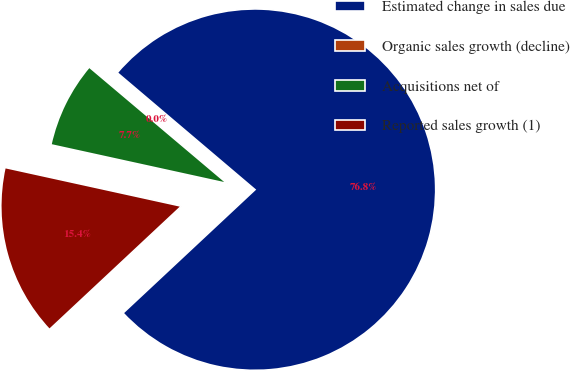<chart> <loc_0><loc_0><loc_500><loc_500><pie_chart><fcel>Estimated change in sales due<fcel>Organic sales growth (decline)<fcel>Acquisitions net of<fcel>Reported sales growth (1)<nl><fcel>76.84%<fcel>0.04%<fcel>7.72%<fcel>15.4%<nl></chart> 